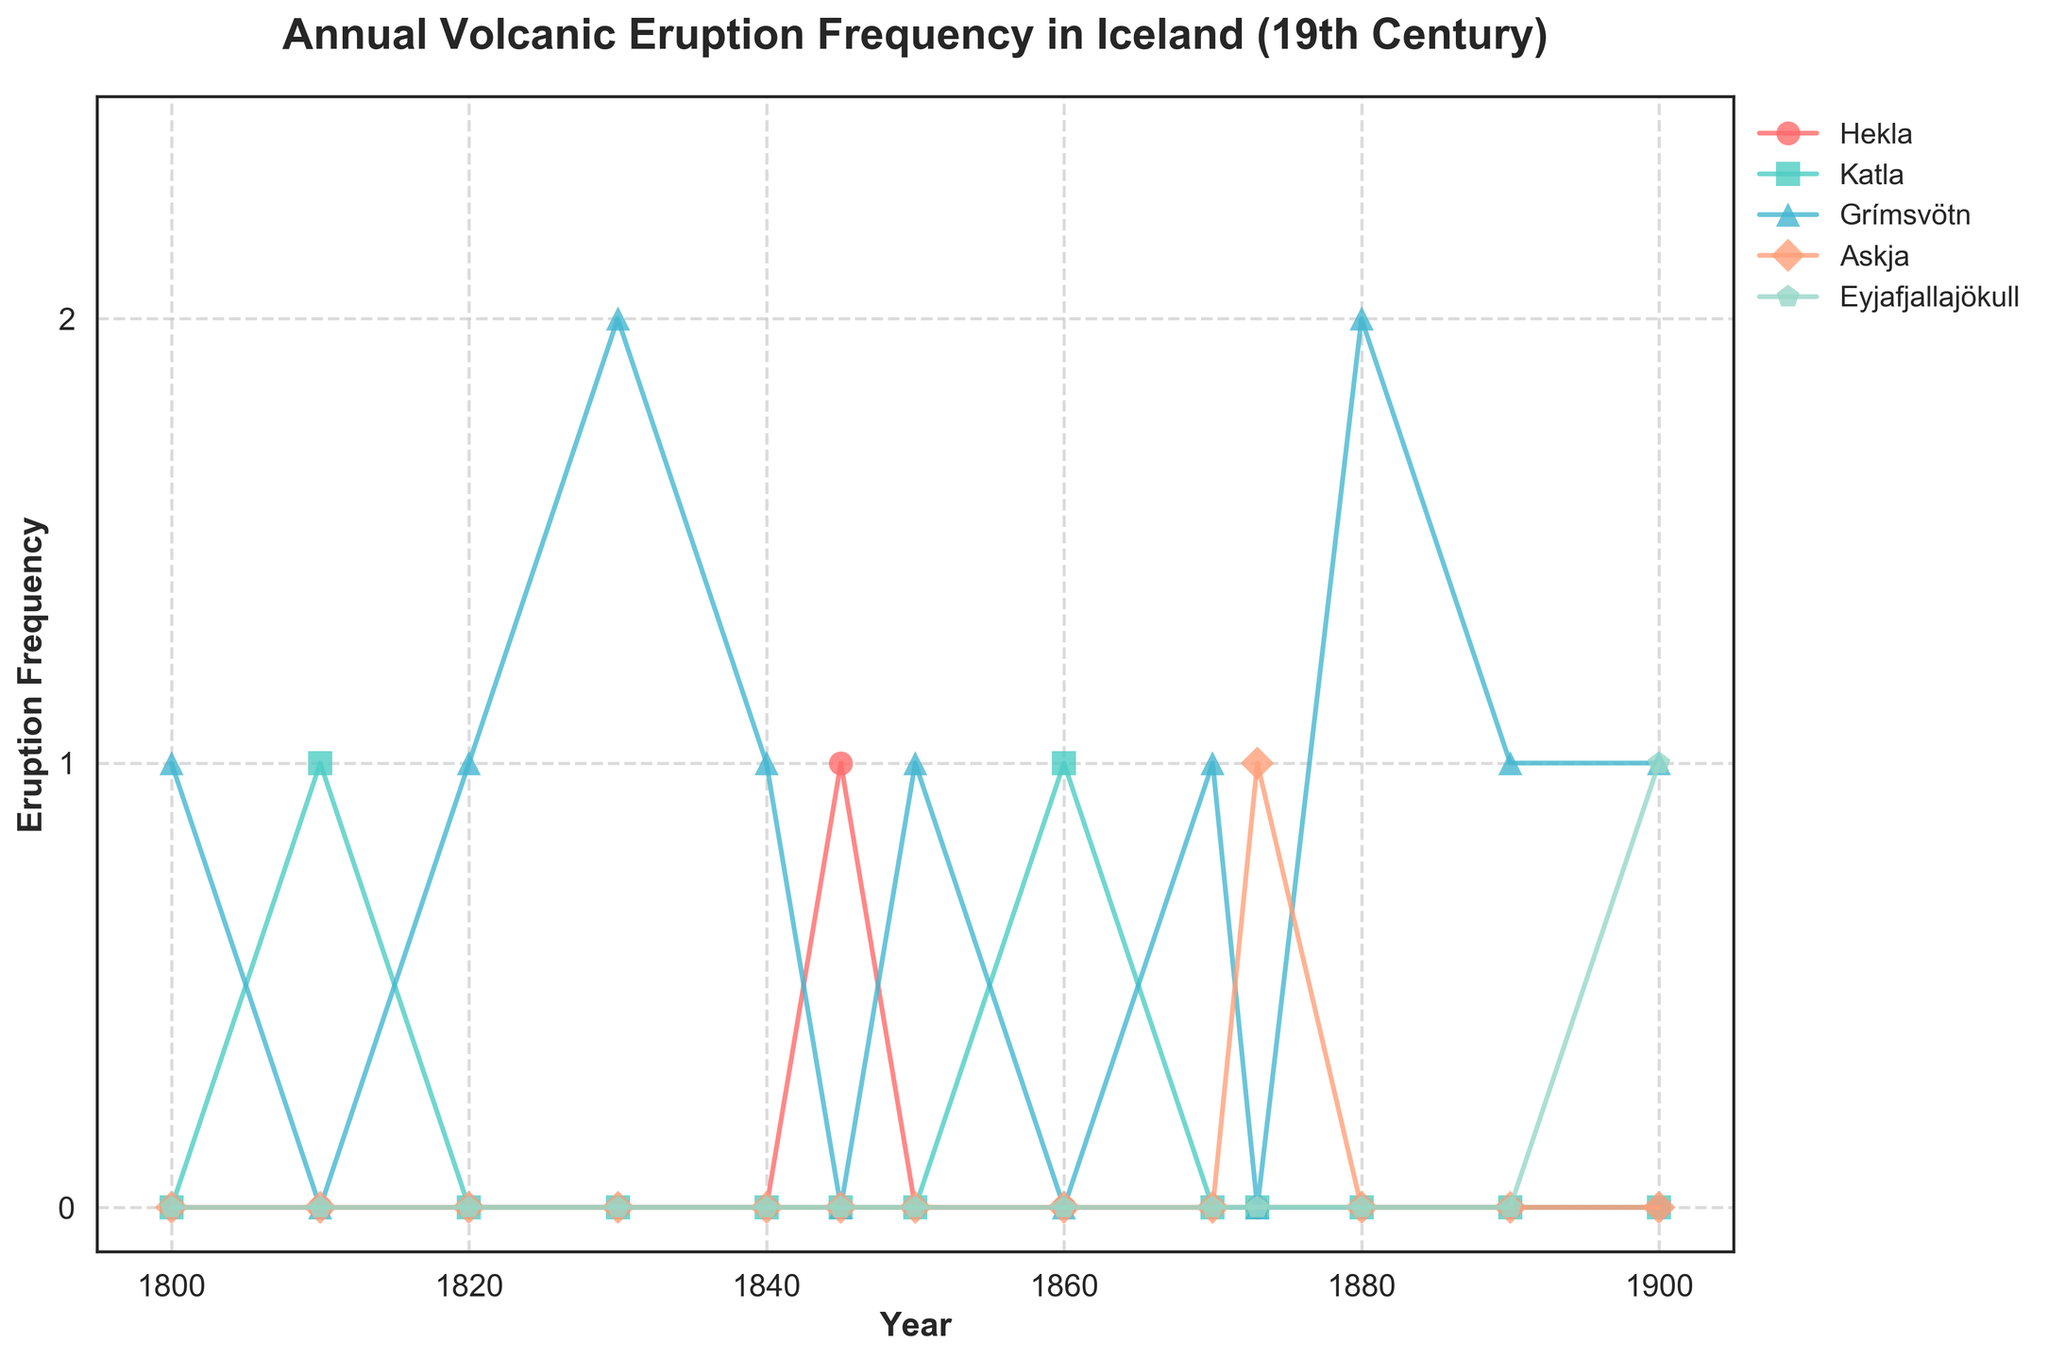What year did Grímsvötn have the highest eruption frequency? Grímsvötn had the highest eruption frequency in 1830, when it erupted twice. This is indicated by the peak in the line corresponding to Grímsvötn.
Answer: 1830 Between Hekla and Eyjafjallajökull, which volcano had eruptions in more distinct years during the 19th century? Hekla erupted in one distinct year (1845), while Eyjafjallajökull erupted in one distinct year (1900). Thus, both volcanos erupted in the same number of distinct years.
Answer: Same number How many total eruptions did Grímsvötn have in the 19th century? Summing up the eruptions of Grímsvötn over the timeline gives us 1 (1800) + 1 (1820) + 2 (1830) + 1 (1840) + 1 (1850) + 1 (1870) + 2 (1880) + 1 (1890) + 1 (1900) = 11 eruptions.
Answer: 11 Which volcano had its first eruption in 1873? Based on the plot, Askja had its first eruption in 1873, as indicated by the peak in that year.
Answer: Askja Is there any year when more than one volcano erupted simultaneously? The figure shows that there are no years with simultaneous eruptions of more than one volcano.
Answer: No What color represents the Katla volcano in the figure? Katla is represented by the green line in the figure, distinguishable by its unique color compared to the other lines.
Answer: Green Which volcano had the longest period of inactivity based on the provided data? Hekla was inactive from 1800 to 1845, totaling 45 years before its first eruption. This is the longest period of inactivity based on the plot.
Answer: Hekla Which volcano had the most eruptions in the 19th century? Grímsvötn had the most eruptions, with a total of 11 eruptions, as indicated by the highest sum of eruption frequencies in the data.
Answer: Grímsvötn Compare the frequency of eruptions between Katla and Askja. Which volcano had more eruptions? Katla had eruptions in 1810 and 1860, totaling 2 eruptions, while Askja erupted once in 1873. Thus, Katla had more eruptions.
Answer: Katla 